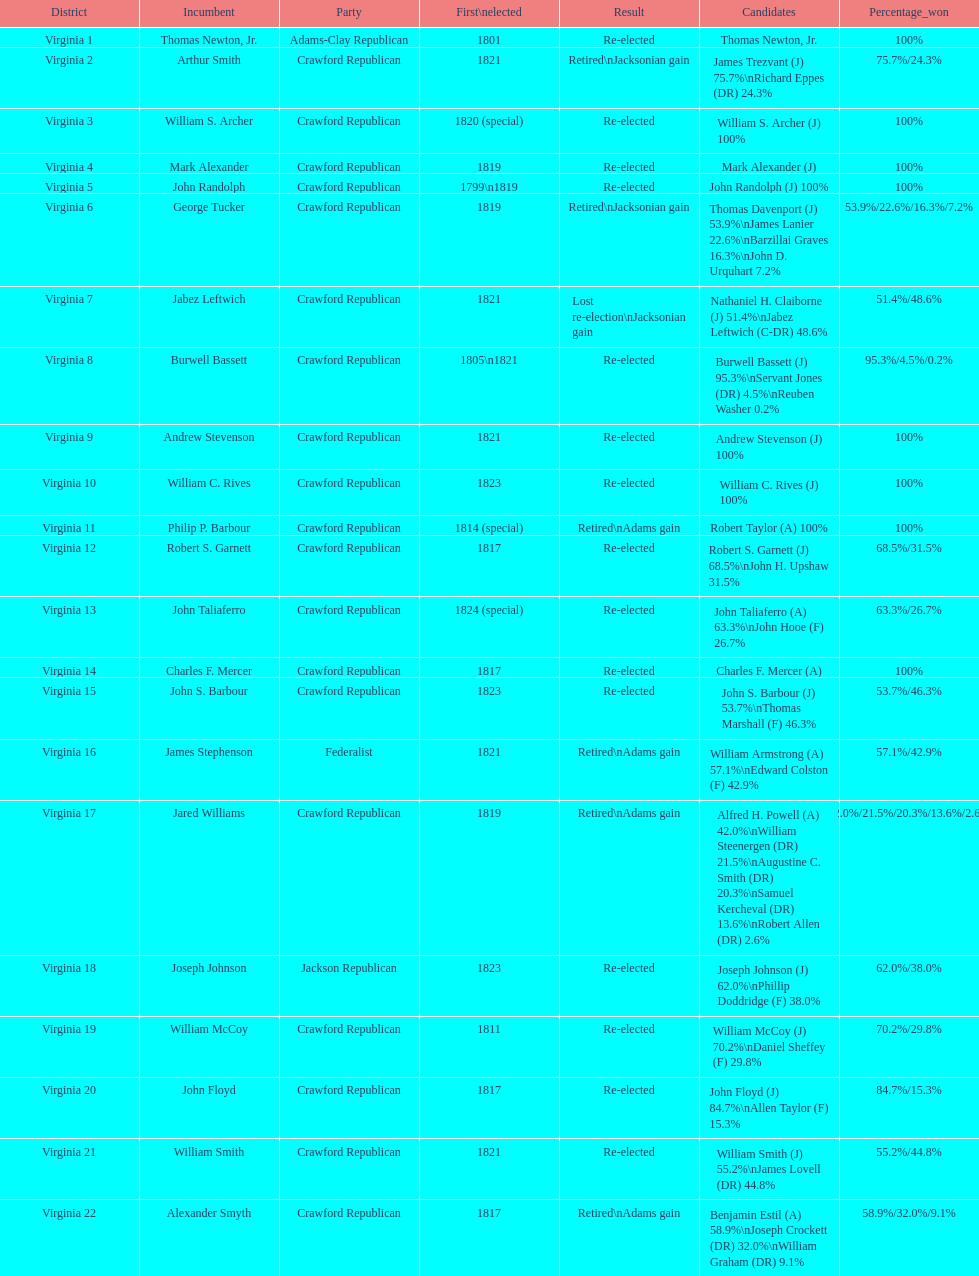Tell me the number of people first elected in 1817. 4. 